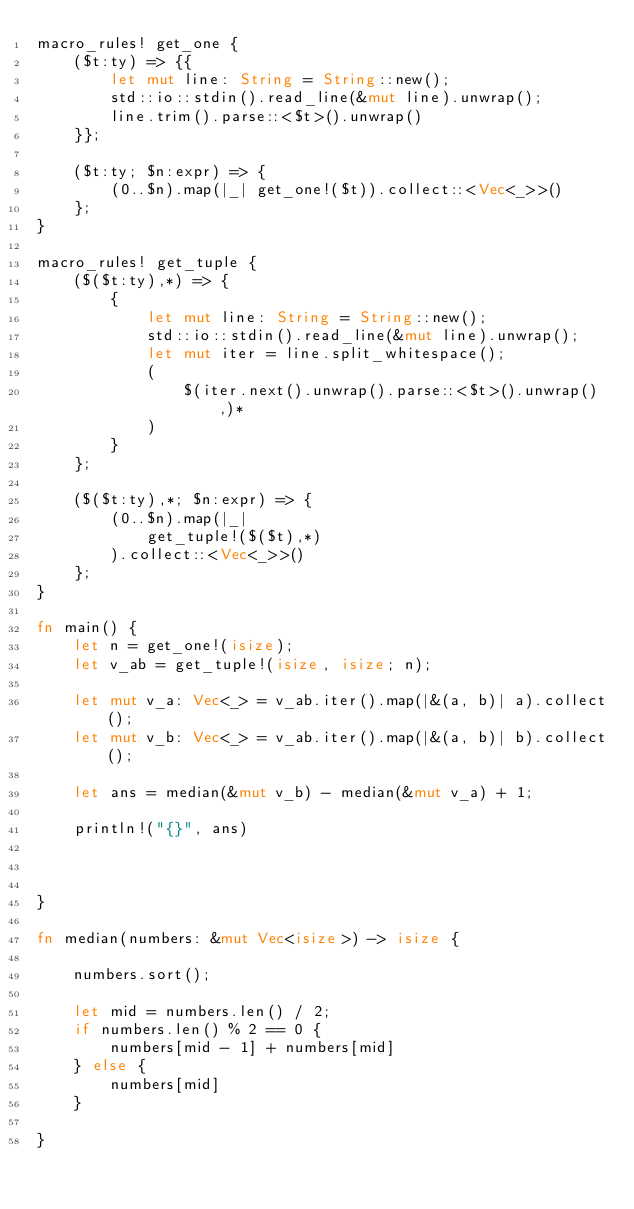<code> <loc_0><loc_0><loc_500><loc_500><_Rust_>macro_rules! get_one {
    ($t:ty) => {{
        let mut line: String = String::new();
        std::io::stdin().read_line(&mut line).unwrap();
        line.trim().parse::<$t>().unwrap()
    }};

    ($t:ty; $n:expr) => {
        (0..$n).map(|_| get_one!($t)).collect::<Vec<_>>()
    };
}

macro_rules! get_tuple {
    ($($t:ty),*) => {
        {
            let mut line: String = String::new();
            std::io::stdin().read_line(&mut line).unwrap();
            let mut iter = line.split_whitespace();
            (
                $(iter.next().unwrap().parse::<$t>().unwrap(),)*
            )
        }
    };

    ($($t:ty),*; $n:expr) => {
        (0..$n).map(|_|
            get_tuple!($($t),*)
        ).collect::<Vec<_>>()
    };
}

fn main() {
    let n = get_one!(isize);
    let v_ab = get_tuple!(isize, isize; n);

    let mut v_a: Vec<_> = v_ab.iter().map(|&(a, b)| a).collect();
    let mut v_b: Vec<_> = v_ab.iter().map(|&(a, b)| b).collect();

    let ans = median(&mut v_b) - median(&mut v_a) + 1;

    println!("{}", ans)



}

fn median(numbers: &mut Vec<isize>) -> isize {

    numbers.sort();

    let mid = numbers.len() / 2;
    if numbers.len() % 2 == 0 {
        numbers[mid - 1] + numbers[mid]
    } else {
        numbers[mid]
    }

}
</code> 